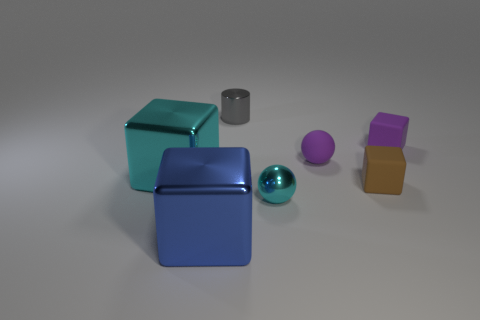What is the size of the cyan object on the left side of the big blue metal object?
Make the answer very short. Large. There is a brown object that is the same size as the cyan ball; what material is it?
Your answer should be compact. Rubber. How big is the purple block right of the cyan metal object on the left side of the small shiny object in front of the gray object?
Provide a succinct answer. Small. What is the size of the cyan ball that is made of the same material as the tiny gray cylinder?
Offer a terse response. Small. Is the size of the gray object the same as the ball that is behind the tiny cyan metal object?
Provide a succinct answer. Yes. What shape is the shiny object that is right of the gray thing?
Provide a short and direct response. Sphere. Is there a cube that is in front of the small sphere on the right side of the small cyan object that is right of the tiny gray cylinder?
Provide a short and direct response. Yes. There is another small object that is the same shape as the small brown thing; what material is it?
Offer a terse response. Rubber. How many cylinders are tiny cyan things or tiny purple objects?
Offer a very short reply. 0. Is the size of the matte cube in front of the big cyan block the same as the purple matte thing in front of the tiny purple matte block?
Make the answer very short. Yes. 